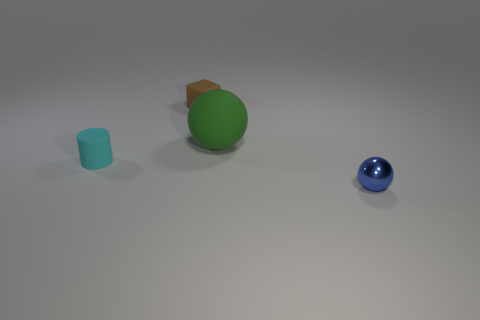Add 1 large yellow rubber spheres. How many objects exist? 5 Add 4 metallic things. How many metallic things are left? 5 Add 2 brown matte cubes. How many brown matte cubes exist? 3 Subtract 0 purple balls. How many objects are left? 4 Subtract all big green rubber objects. Subtract all small brown matte objects. How many objects are left? 2 